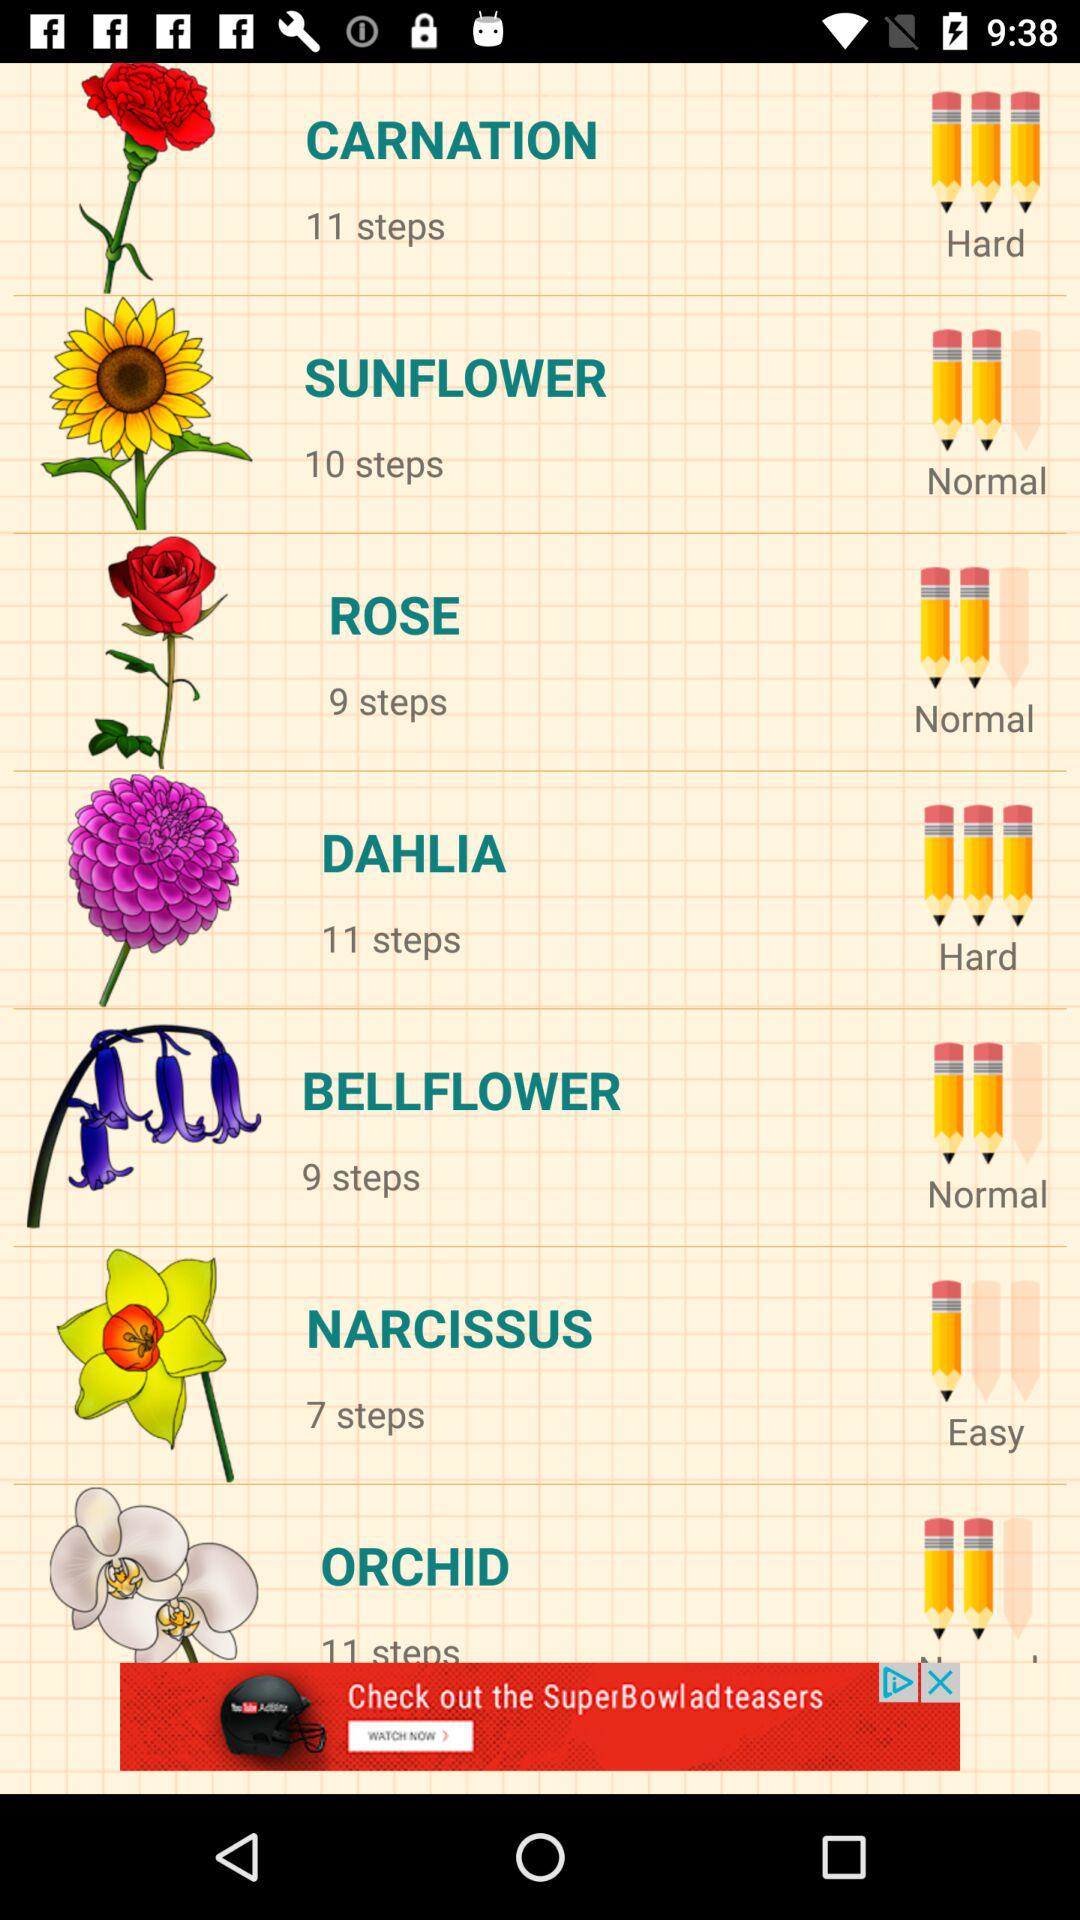How many steps are in the flower drawing with the most steps?
Answer the question using a single word or phrase. 11 